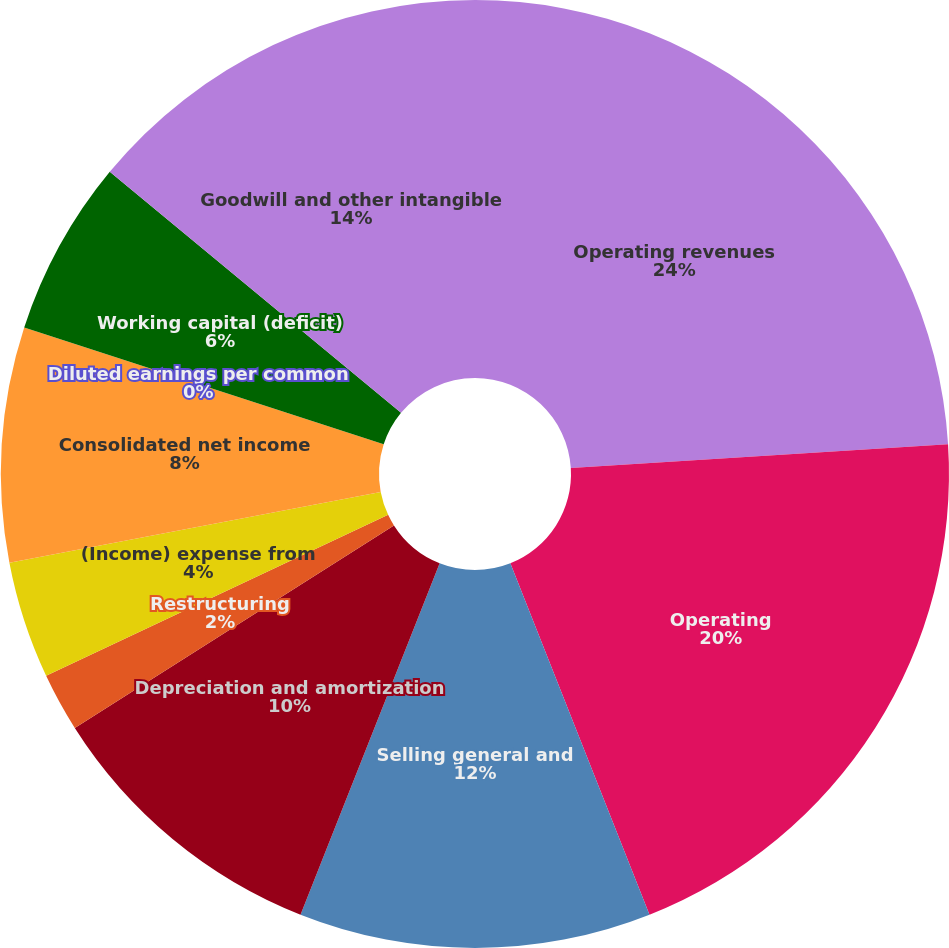Convert chart. <chart><loc_0><loc_0><loc_500><loc_500><pie_chart><fcel>Operating revenues<fcel>Operating<fcel>Selling general and<fcel>Depreciation and amortization<fcel>Restructuring<fcel>(Income) expense from<fcel>Consolidated net income<fcel>Diluted earnings per common<fcel>Working capital (deficit)<fcel>Goodwill and other intangible<nl><fcel>24.0%<fcel>20.0%<fcel>12.0%<fcel>10.0%<fcel>2.0%<fcel>4.0%<fcel>8.0%<fcel>0.0%<fcel>6.0%<fcel>14.0%<nl></chart> 